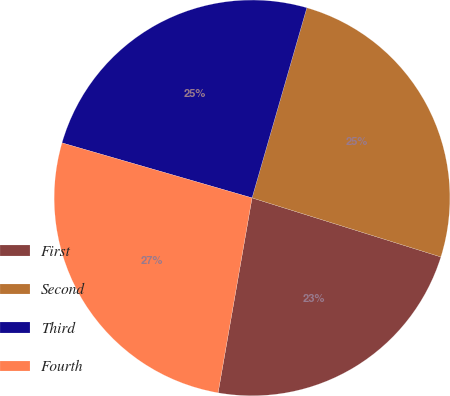<chart> <loc_0><loc_0><loc_500><loc_500><pie_chart><fcel>First<fcel>Second<fcel>Third<fcel>Fourth<nl><fcel>22.92%<fcel>25.36%<fcel>24.98%<fcel>26.74%<nl></chart> 